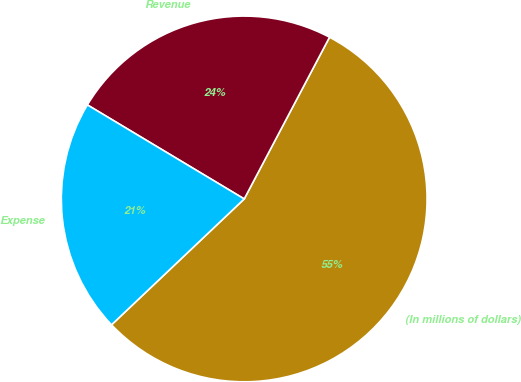Convert chart. <chart><loc_0><loc_0><loc_500><loc_500><pie_chart><fcel>(In millions of dollars)<fcel>Revenue<fcel>Expense<nl><fcel>55.2%<fcel>24.13%<fcel>20.68%<nl></chart> 